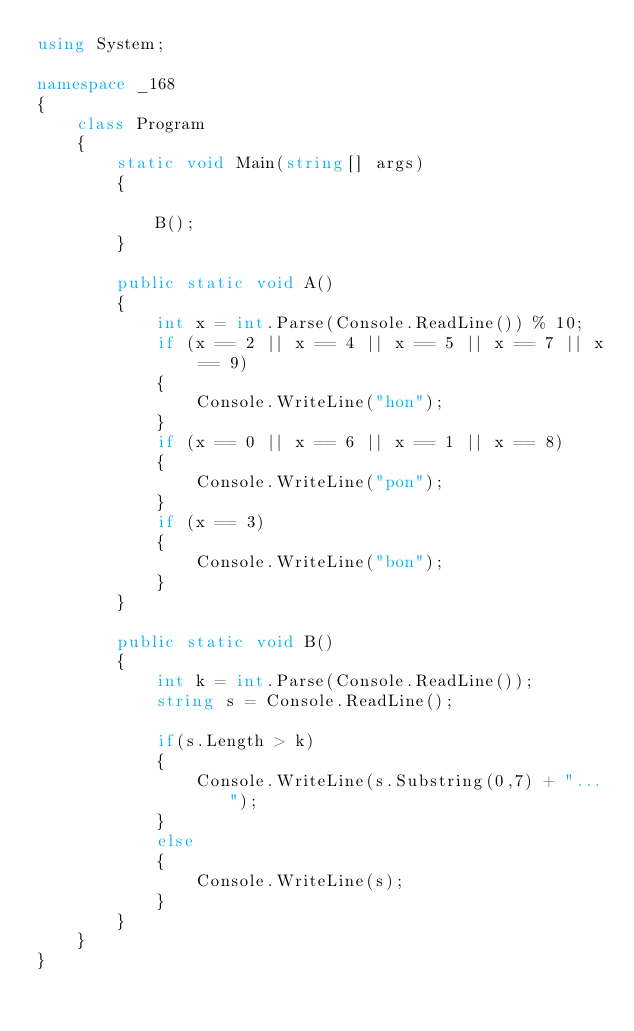Convert code to text. <code><loc_0><loc_0><loc_500><loc_500><_C#_>using System;

namespace _168
{
    class Program
    {
        static void Main(string[] args)
        {

            B();
        }

        public static void A()
        {
            int x = int.Parse(Console.ReadLine()) % 10;
            if (x == 2 || x == 4 || x == 5 || x == 7 || x == 9)
            {
                Console.WriteLine("hon");
            }
            if (x == 0 || x == 6 || x == 1 || x == 8)
            {
                Console.WriteLine("pon");
            }
            if (x == 3)
            {
                Console.WriteLine("bon");
            }
        }

        public static void B()
        {
            int k = int.Parse(Console.ReadLine());
            string s = Console.ReadLine();

            if(s.Length > k)
            {
                Console.WriteLine(s.Substring(0,7) + "...");
            }
            else
            {
                Console.WriteLine(s);
            }
        }
    }
}
</code> 